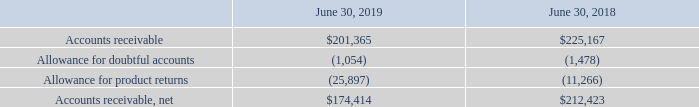Accounts Receivable
The following is a summary of Accounts receivable (in thousands):
Which years does the table provide information for the company's Accounts receivable? 2019, 2018. What was the amount of accounts receivable in 2018?
Answer scale should be: thousand. 225,167. What was the allowance for product returns in 2019?
Answer scale should be: thousand. (25,897). How many years did the net accounts receivable exceed $200,000 thousand? 2018
Answer: 1. What was the change in the Allowance for doubtful accounts between 2018 and 2019?
Answer scale should be: thousand. -1,054-(-1,478)
Answer: 424. What was the percentage change in the Allowance for product returns between 2018 and 2019?
Answer scale should be: percent. (-25,897+11,266)/-11,266
Answer: 129.87. 